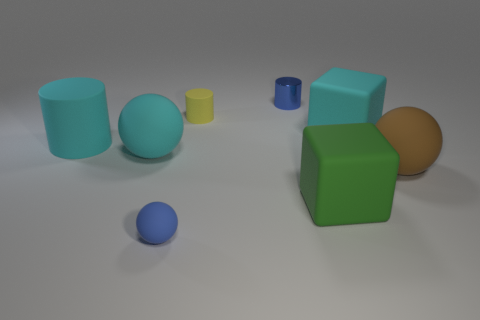Subtract all red cylinders. Subtract all blue balls. How many cylinders are left? 3 Add 2 large blocks. How many objects exist? 10 Subtract all spheres. How many objects are left? 5 Subtract all big cyan rubber cylinders. Subtract all small blue objects. How many objects are left? 5 Add 7 blue things. How many blue things are left? 9 Add 8 big matte spheres. How many big matte spheres exist? 10 Subtract 0 yellow blocks. How many objects are left? 8 